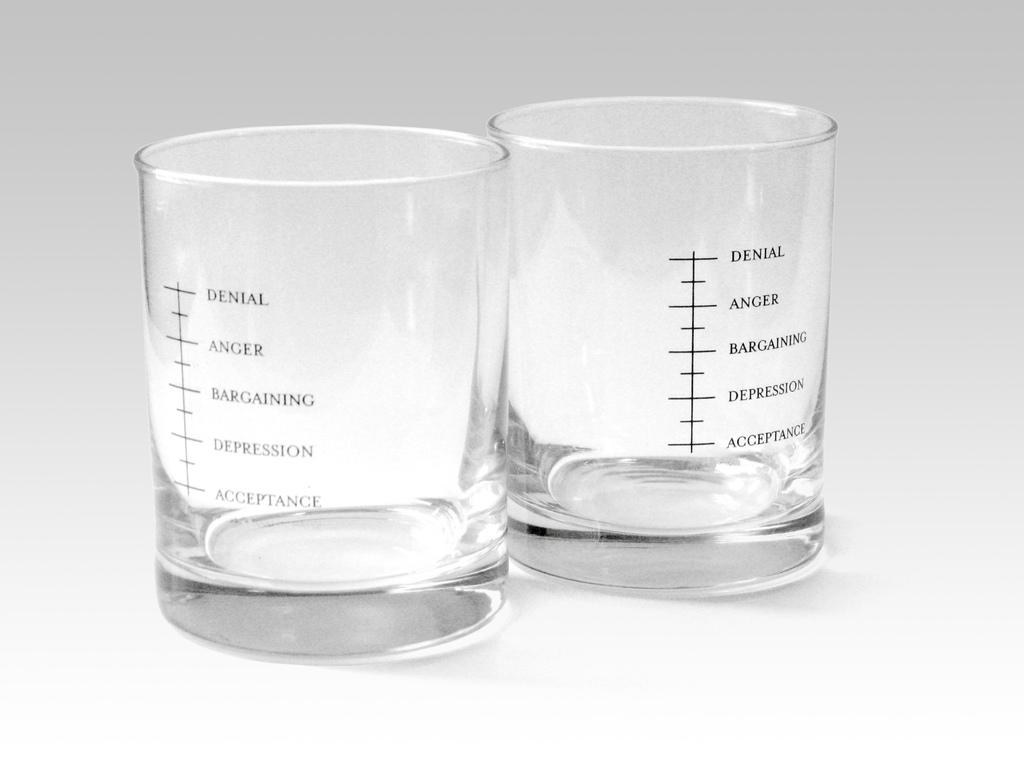<image>
Offer a succinct explanation of the picture presented. Two shot glasses show how much to pour to treat things like anger and denial. 